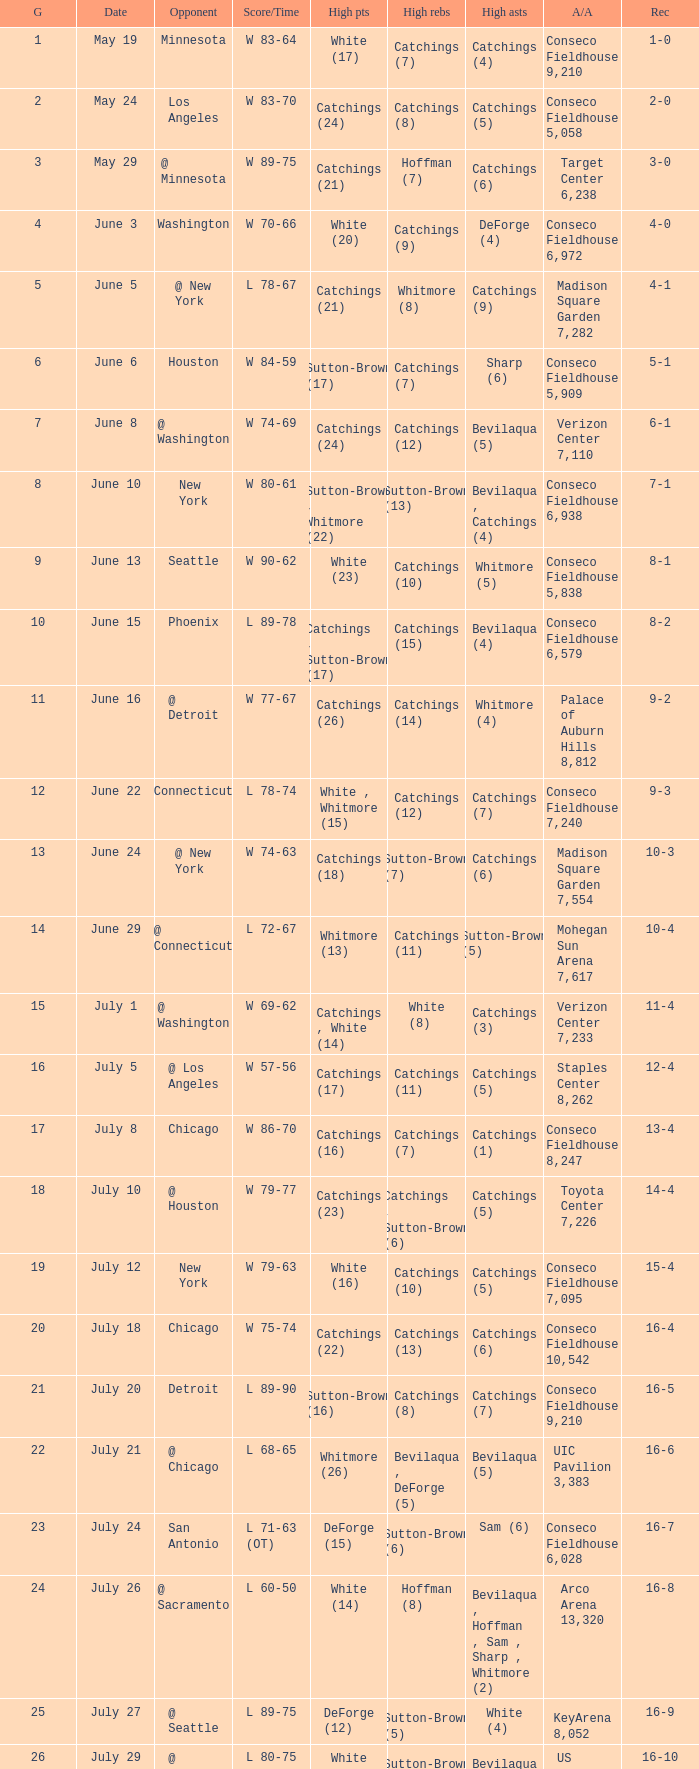Name the date where score time is w 74-63 June 24. 